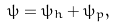Convert formula to latex. <formula><loc_0><loc_0><loc_500><loc_500>\psi = \psi _ { h } + \psi _ { p } ,</formula> 